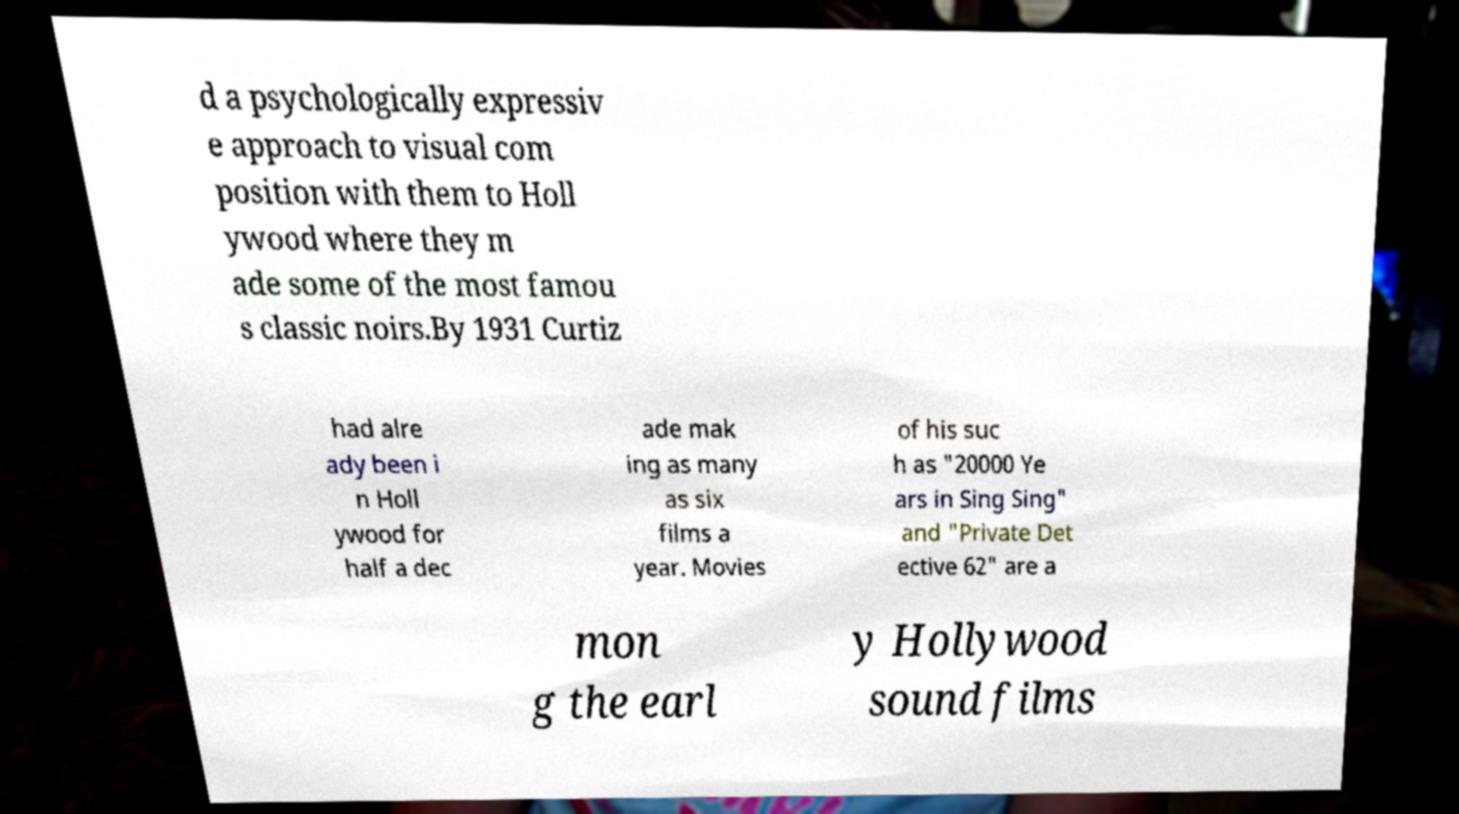There's text embedded in this image that I need extracted. Can you transcribe it verbatim? d a psychologically expressiv e approach to visual com position with them to Holl ywood where they m ade some of the most famou s classic noirs.By 1931 Curtiz had alre ady been i n Holl ywood for half a dec ade mak ing as many as six films a year. Movies of his suc h as "20000 Ye ars in Sing Sing" and "Private Det ective 62" are a mon g the earl y Hollywood sound films 